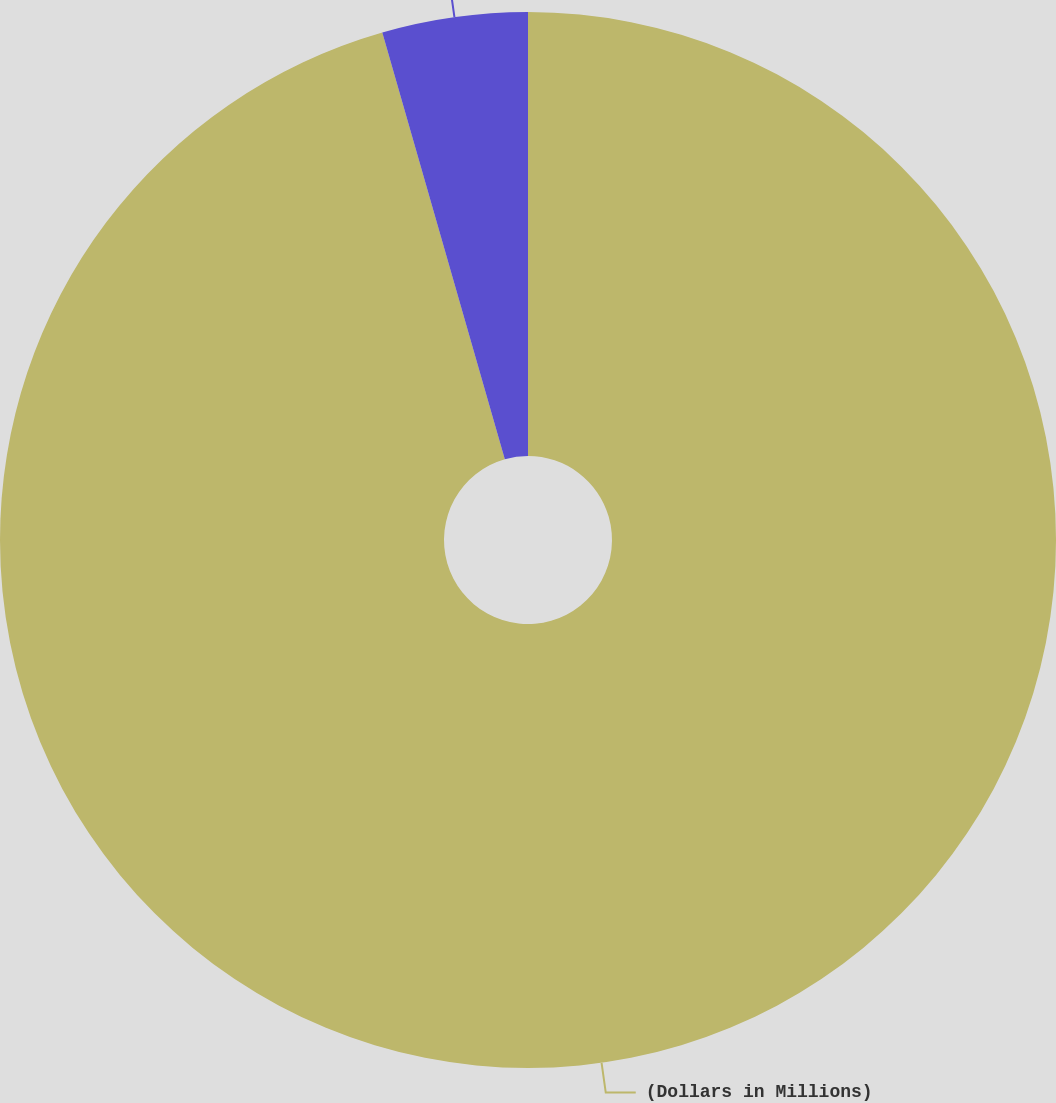Convert chart to OTSL. <chart><loc_0><loc_0><loc_500><loc_500><pie_chart><fcel>(Dollars in Millions)<fcel>Projected future contributions<nl><fcel>95.55%<fcel>4.45%<nl></chart> 